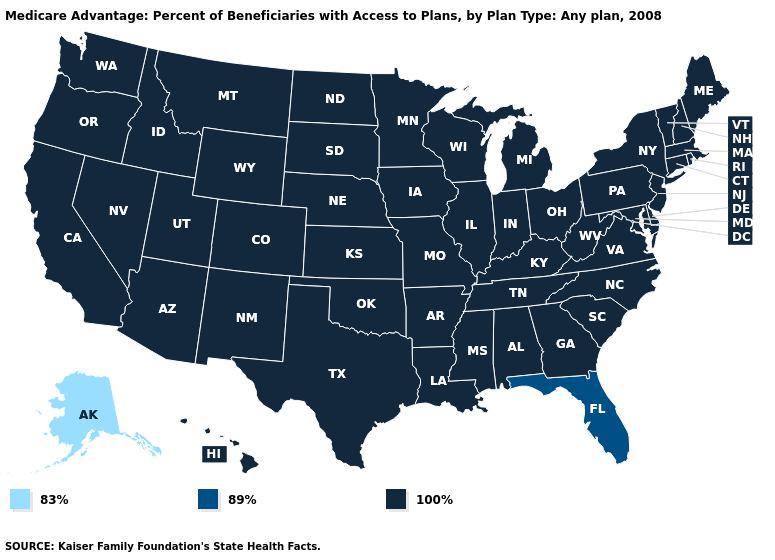What is the highest value in the USA?
Keep it brief. 100%. What is the value of Colorado?
Give a very brief answer. 100%. What is the highest value in the West ?
Short answer required. 100%. Which states have the highest value in the USA?
Give a very brief answer. Alabama, Arkansas, Arizona, California, Colorado, Connecticut, Delaware, Georgia, Hawaii, Iowa, Idaho, Illinois, Indiana, Kansas, Kentucky, Louisiana, Massachusetts, Maryland, Maine, Michigan, Minnesota, Missouri, Mississippi, Montana, North Carolina, North Dakota, Nebraska, New Hampshire, New Jersey, New Mexico, Nevada, New York, Ohio, Oklahoma, Oregon, Pennsylvania, Rhode Island, South Carolina, South Dakota, Tennessee, Texas, Utah, Virginia, Vermont, Washington, Wisconsin, West Virginia, Wyoming. Does Wyoming have the same value as California?
Be succinct. Yes. Name the states that have a value in the range 83%?
Concise answer only. Alaska. Among the states that border South Carolina , which have the highest value?
Give a very brief answer. Georgia, North Carolina. Among the states that border New Hampshire , which have the lowest value?
Quick response, please. Massachusetts, Maine, Vermont. Does Florida have the lowest value in the South?
Keep it brief. Yes. Name the states that have a value in the range 89%?
Keep it brief. Florida. What is the value of Massachusetts?
Concise answer only. 100%. What is the value of Maryland?
Write a very short answer. 100%. What is the value of Louisiana?
Be succinct. 100%. What is the value of Minnesota?
Be succinct. 100%. 